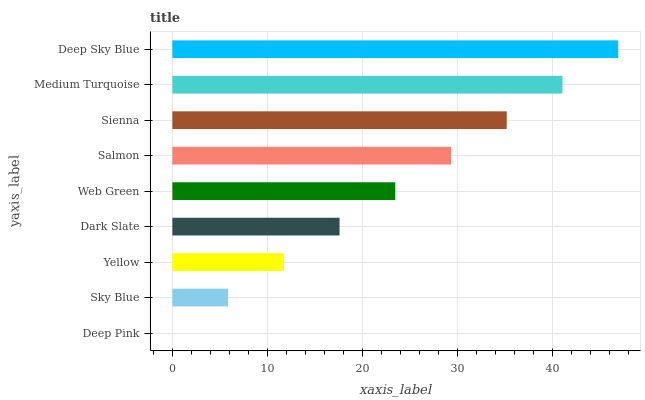Is Deep Pink the minimum?
Answer yes or no. Yes. Is Deep Sky Blue the maximum?
Answer yes or no. Yes. Is Sky Blue the minimum?
Answer yes or no. No. Is Sky Blue the maximum?
Answer yes or no. No. Is Sky Blue greater than Deep Pink?
Answer yes or no. Yes. Is Deep Pink less than Sky Blue?
Answer yes or no. Yes. Is Deep Pink greater than Sky Blue?
Answer yes or no. No. Is Sky Blue less than Deep Pink?
Answer yes or no. No. Is Web Green the high median?
Answer yes or no. Yes. Is Web Green the low median?
Answer yes or no. Yes. Is Salmon the high median?
Answer yes or no. No. Is Sienna the low median?
Answer yes or no. No. 